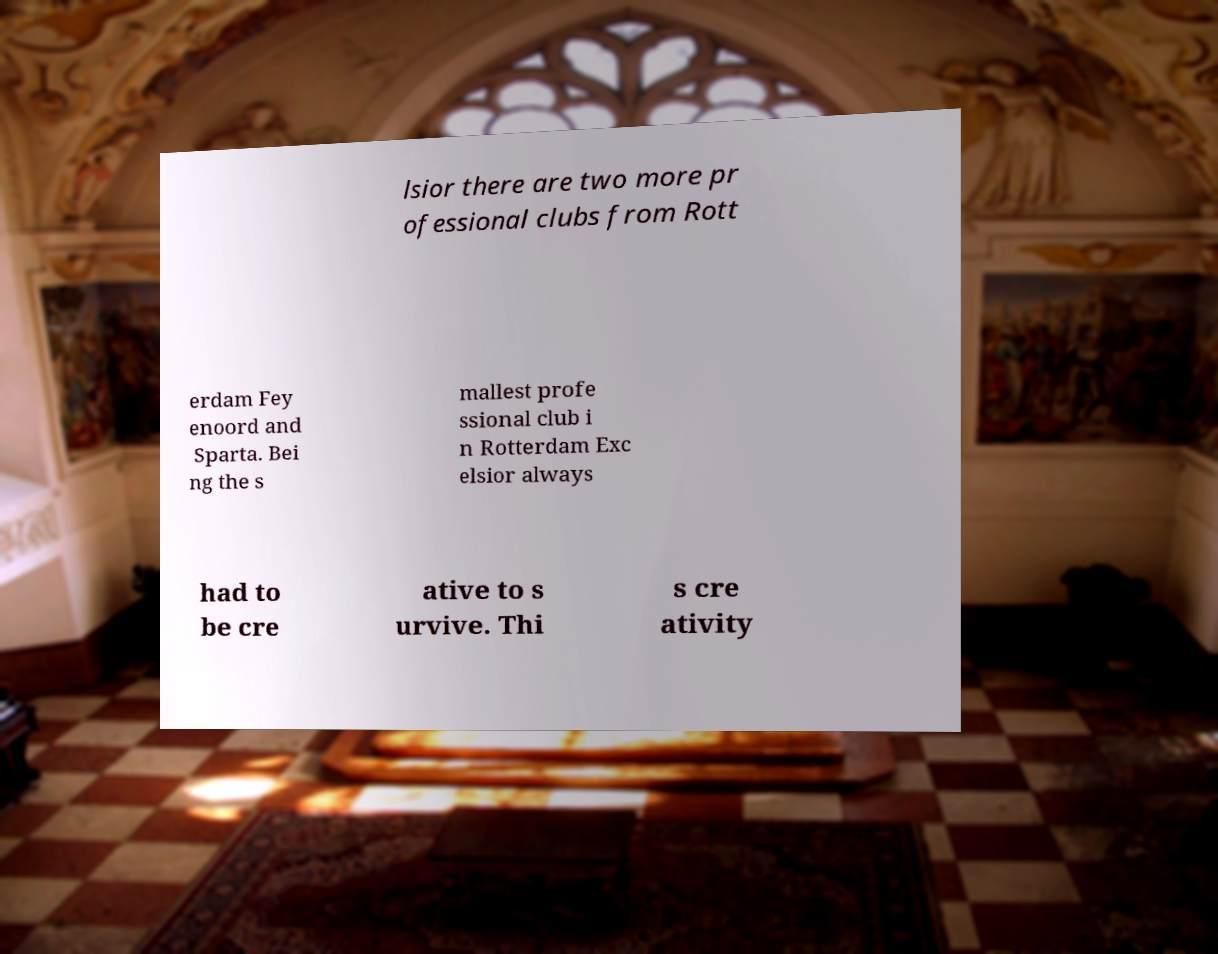For documentation purposes, I need the text within this image transcribed. Could you provide that? lsior there are two more pr ofessional clubs from Rott erdam Fey enoord and Sparta. Bei ng the s mallest profe ssional club i n Rotterdam Exc elsior always had to be cre ative to s urvive. Thi s cre ativity 